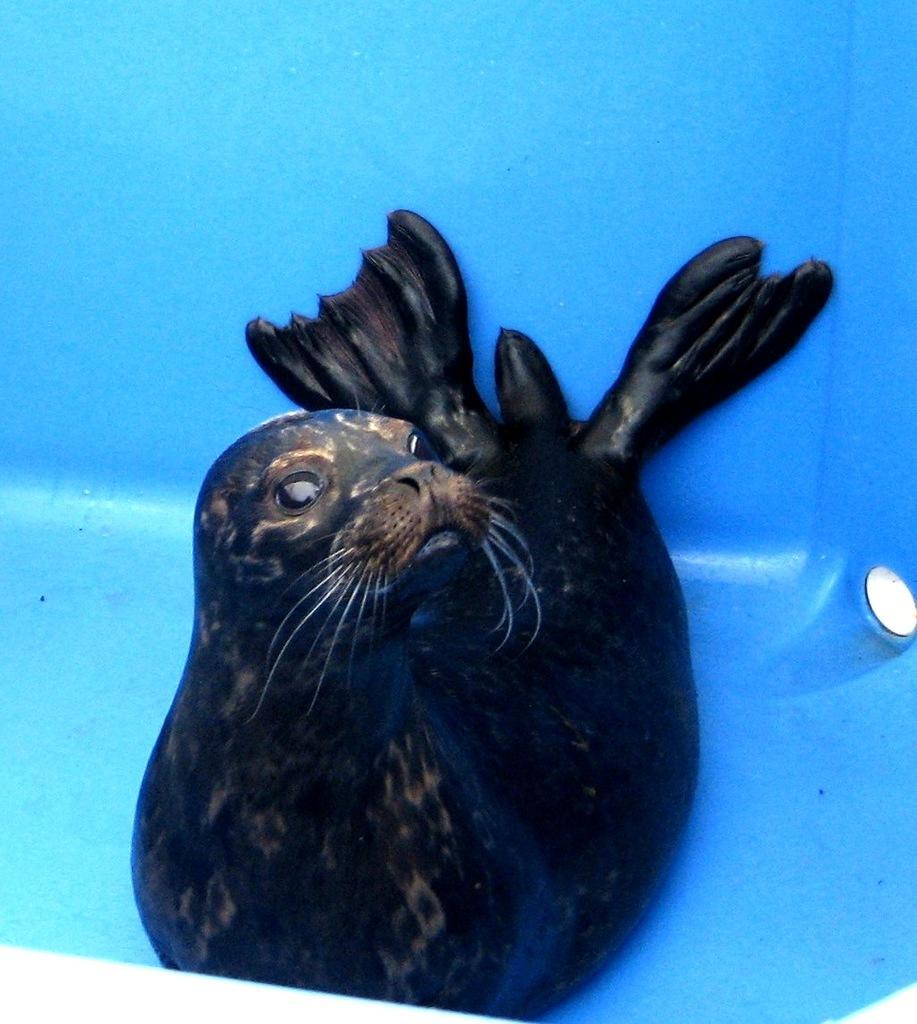Could you give a brief overview of what you see in this image? In this image we can see the sea lion. 